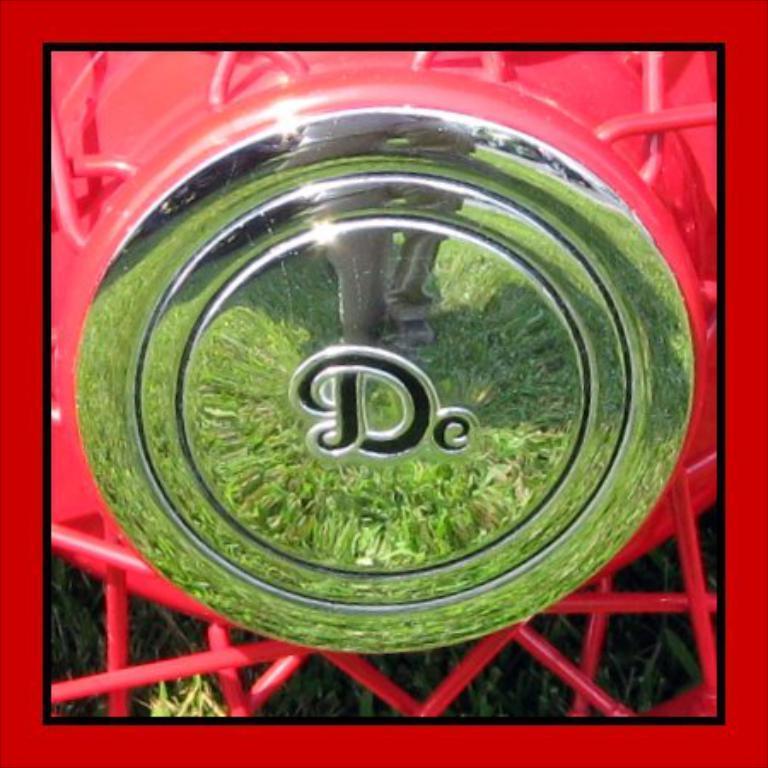Describe this image in one or two sentences. In this image we can see a logo and the reflection of the people and grass, behind the logo we can see the grass. 